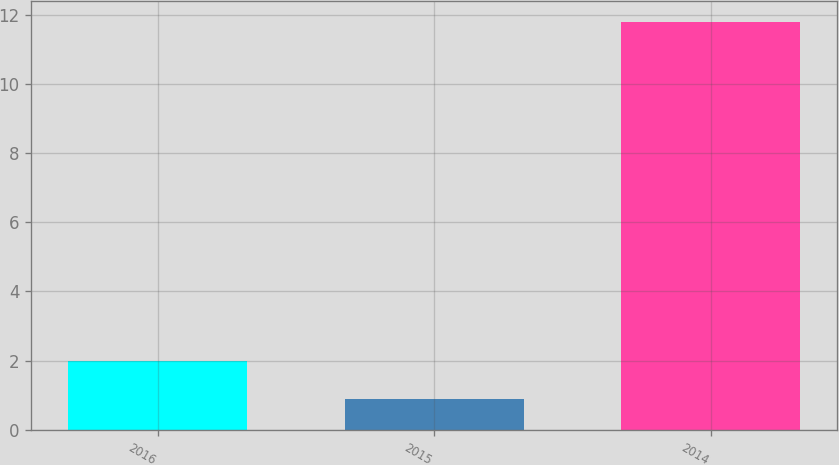<chart> <loc_0><loc_0><loc_500><loc_500><bar_chart><fcel>2016<fcel>2015<fcel>2014<nl><fcel>1.99<fcel>0.9<fcel>11.8<nl></chart> 